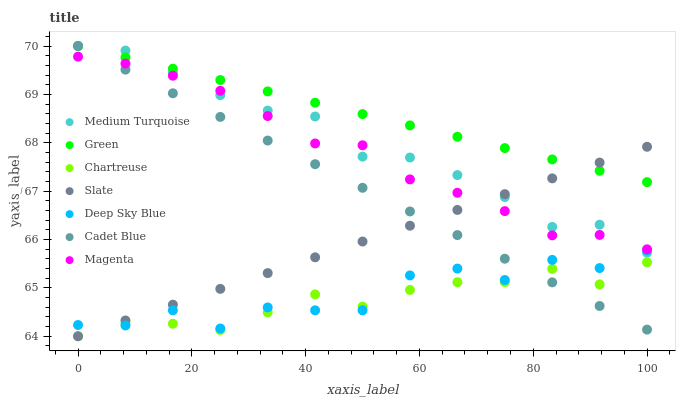Does Chartreuse have the minimum area under the curve?
Answer yes or no. Yes. Does Green have the maximum area under the curve?
Answer yes or no. Yes. Does Medium Turquoise have the minimum area under the curve?
Answer yes or no. No. Does Medium Turquoise have the maximum area under the curve?
Answer yes or no. No. Is Green the smoothest?
Answer yes or no. Yes. Is Deep Sky Blue the roughest?
Answer yes or no. Yes. Is Medium Turquoise the smoothest?
Answer yes or no. No. Is Medium Turquoise the roughest?
Answer yes or no. No. Does Slate have the lowest value?
Answer yes or no. Yes. Does Medium Turquoise have the lowest value?
Answer yes or no. No. Does Green have the highest value?
Answer yes or no. Yes. Does Slate have the highest value?
Answer yes or no. No. Is Magenta less than Green?
Answer yes or no. Yes. Is Magenta greater than Chartreuse?
Answer yes or no. Yes. Does Cadet Blue intersect Deep Sky Blue?
Answer yes or no. Yes. Is Cadet Blue less than Deep Sky Blue?
Answer yes or no. No. Is Cadet Blue greater than Deep Sky Blue?
Answer yes or no. No. Does Magenta intersect Green?
Answer yes or no. No. 